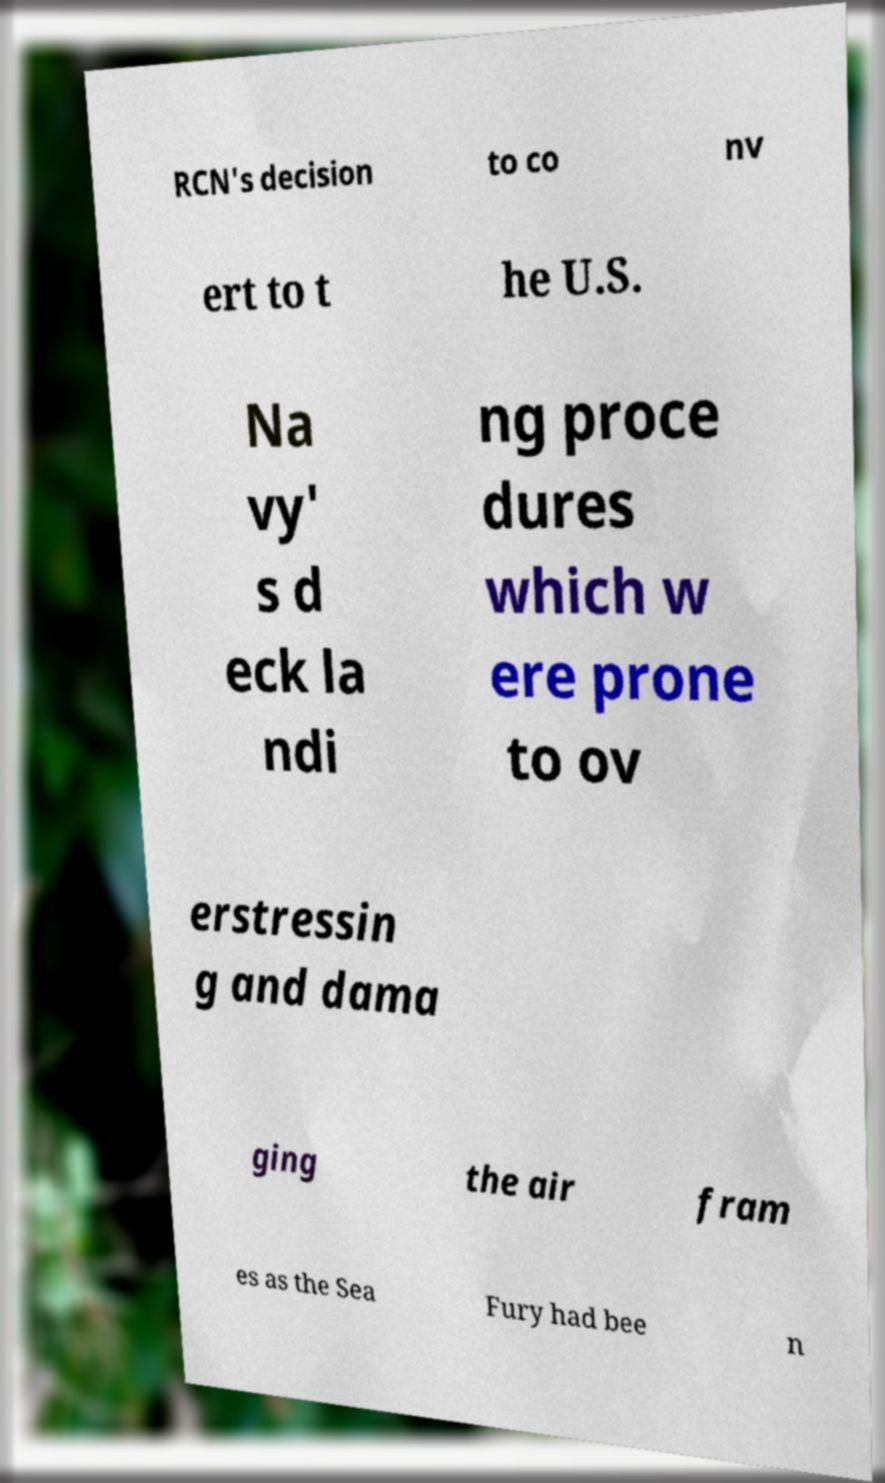Please identify and transcribe the text found in this image. RCN's decision to co nv ert to t he U.S. Na vy' s d eck la ndi ng proce dures which w ere prone to ov erstressin g and dama ging the air fram es as the Sea Fury had bee n 